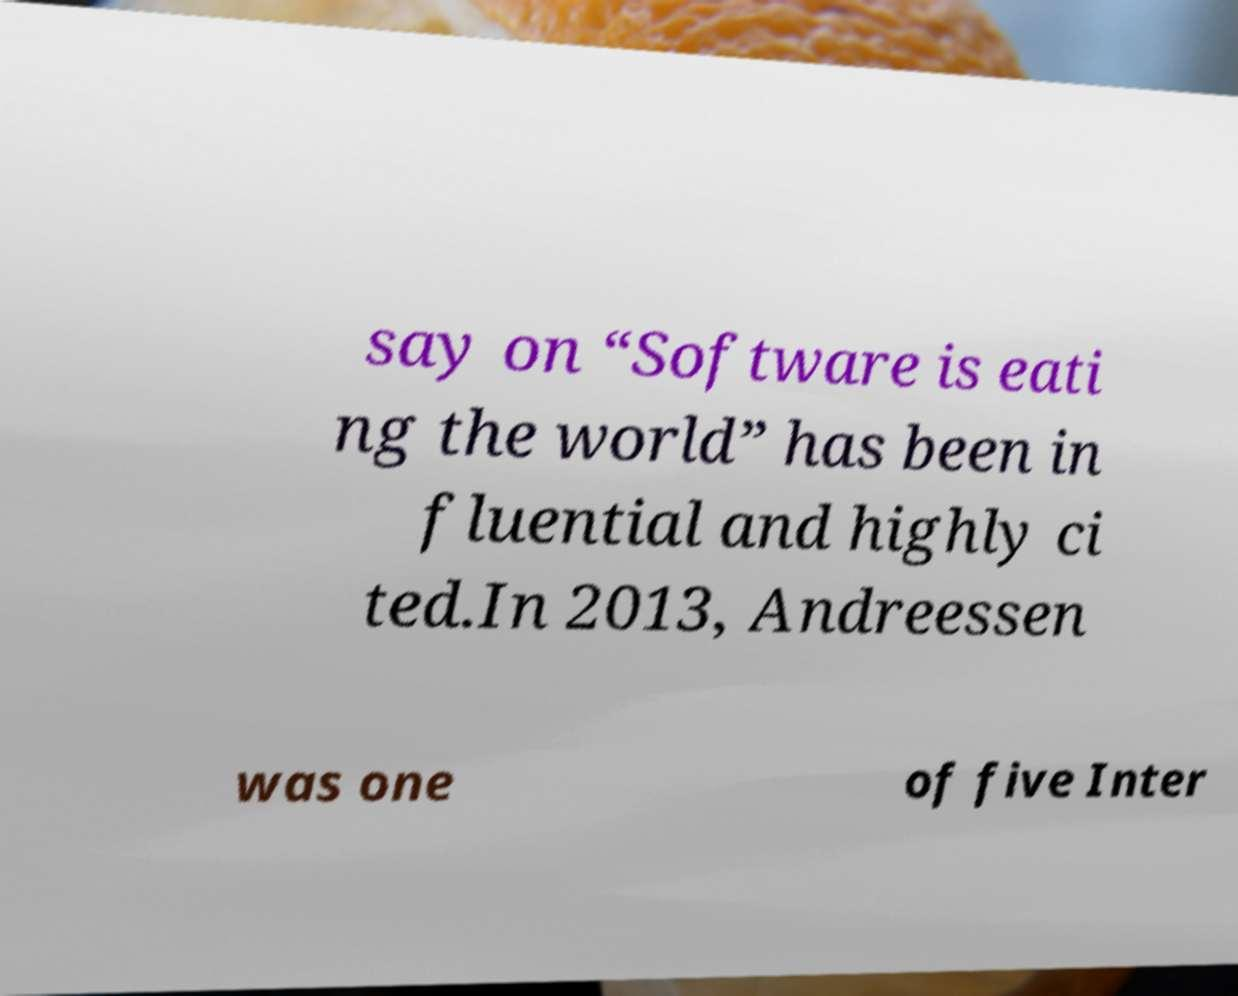What messages or text are displayed in this image? I need them in a readable, typed format. say on “Software is eati ng the world” has been in fluential and highly ci ted.In 2013, Andreessen was one of five Inter 